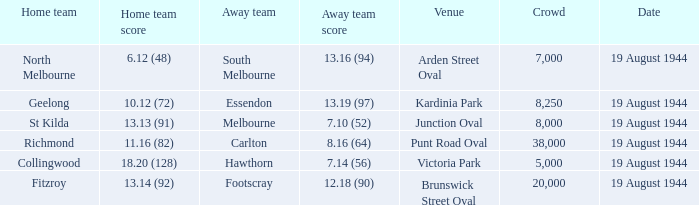What is Fitzroy's Home team score? 13.14 (92). 